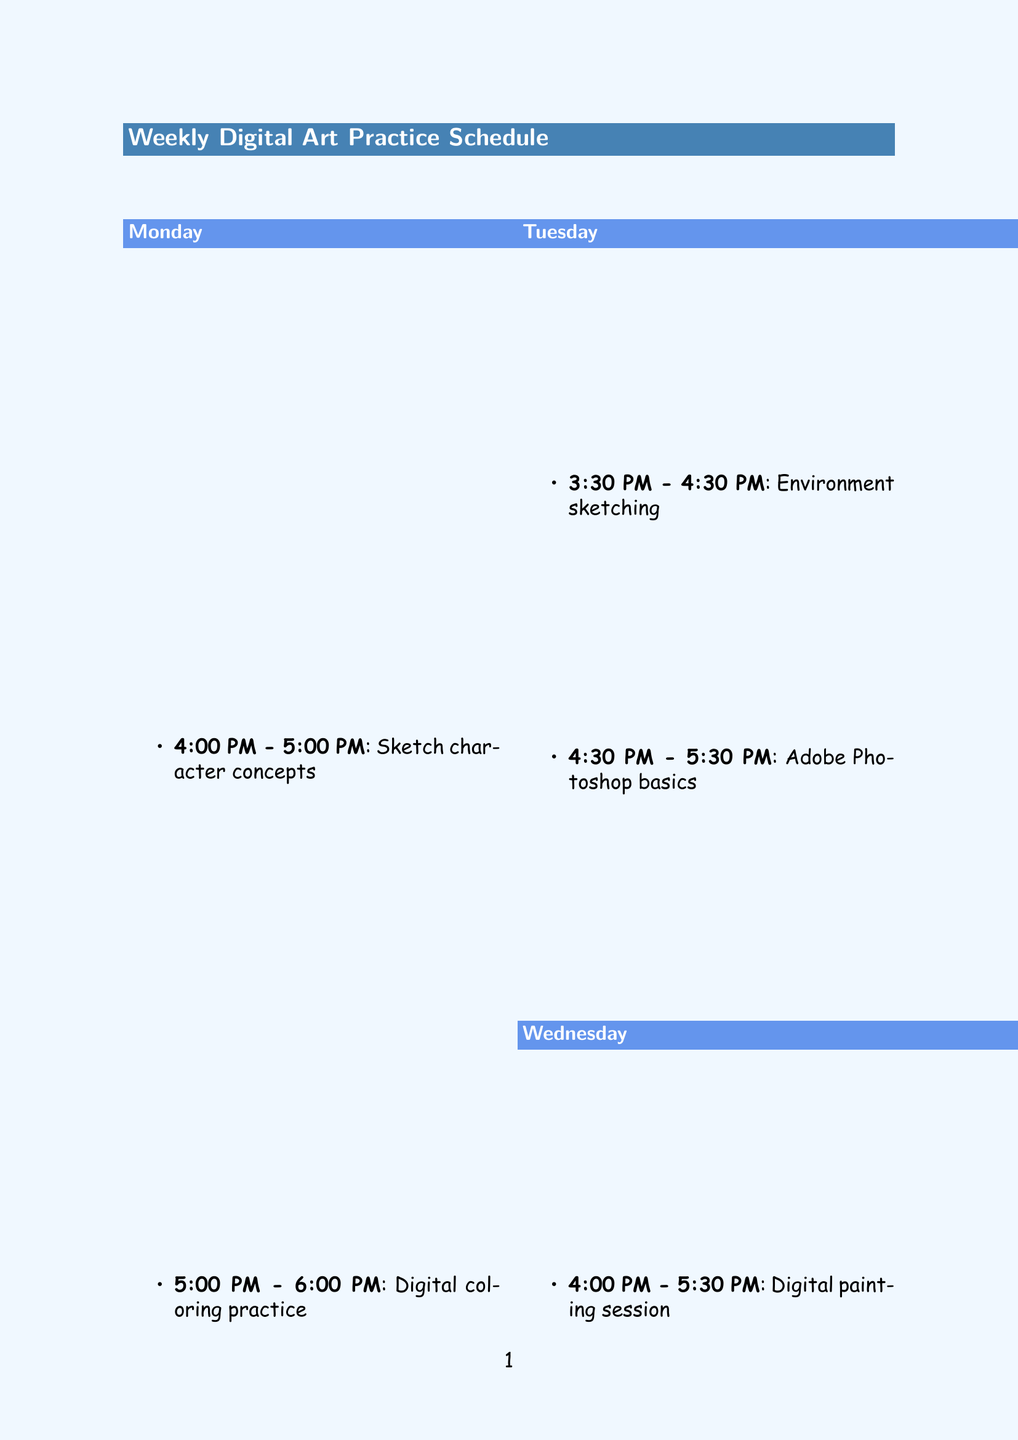What are the two tasks scheduled for Monday? Monday includes tasks for sketching character concepts and digital coloring practice.
Answer: Sketch character concepts, Digital coloring practice What time does the digital painting session start on Wednesday? The digital painting session starts at 4:00 PM on Wednesday.
Answer: 4:00 PM Which tool is used for precise digital drawing and painting? The Wacom Intuos Pro tablet is used for precise digital drawing and painting.
Answer: Wacom Intuos Pro tablet How many activities are planned for Saturday? Saturday has two activities: concept art development and digital art community engagement.
Answer: 2 What is the focus of the storyboard sketching on Thursday? The storyboard sketching focuses on creating a short comic based on a funny anecdote from grandparent.
Answer: Short comic based on a funny anecdote What time does the art style exploration occur on Sunday? The art style exploration occurs from 11:00 AM to 12:30 PM on Sunday.
Answer: 11:00 AM - 12:30 PM What software is mentioned for learning new digital art techniques? Skillshare online classes are mentioned for learning new digital art techniques.
Answer: Skillshare online classes What is one inspiration source for the digital art practice? One inspiration source is the grandparent's photo albums.
Answer: Grandparent's photo albums 